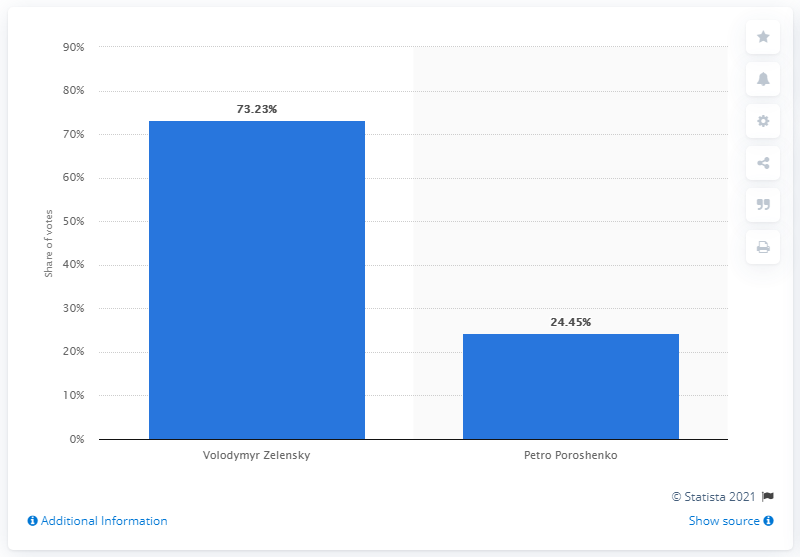Indicate a few pertinent items in this graphic. Volodymyr Zelensky received the highest percentage of votes in the second round of the Ukrainian presidential elections in 2019. Petro Poroshenko is the current president of Ukraine. The winner of the second round of the presidential election in Ukraine was Volodymyr Zelensky. The difference in the vote share between the two candidates in the second round of the Ukrainian presidential elections in 2019 was 48.78%. 